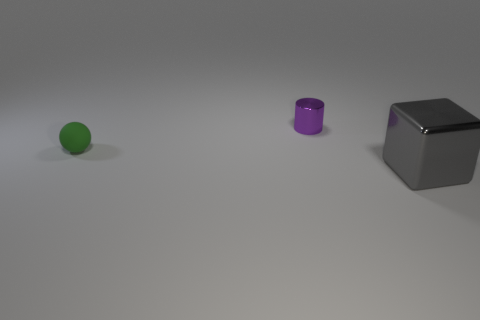There is a object that is on the right side of the metallic object that is to the left of the object that is in front of the matte object; what is its material?
Give a very brief answer. Metal. Are there more tiny green matte things that are to the left of the small green object than cylinders that are in front of the small cylinder?
Offer a very short reply. No. What number of metallic objects are cubes or tiny purple objects?
Your answer should be compact. 2. There is a object behind the tiny green matte thing; what is it made of?
Offer a terse response. Metal. What number of objects are gray metallic cubes or small things that are behind the green sphere?
Offer a terse response. 2. What shape is the matte object that is the same size as the purple metal thing?
Offer a very short reply. Sphere. Does the small object that is left of the purple object have the same material as the gray object?
Make the answer very short. No. There is a gray shiny object; what shape is it?
Offer a very short reply. Cube. How many gray objects are either shiny cubes or rubber things?
Provide a succinct answer. 1. How many other things are made of the same material as the gray thing?
Offer a terse response. 1. 